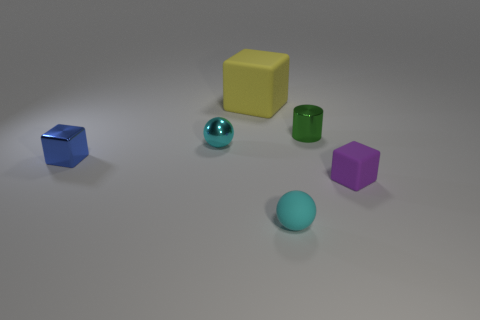Add 2 blue metal things. How many objects exist? 8 Subtract all cylinders. How many objects are left? 5 Subtract 0 yellow cylinders. How many objects are left? 6 Subtract all big yellow matte cubes. Subtract all small red metallic spheres. How many objects are left? 5 Add 1 metallic objects. How many metallic objects are left? 4 Add 6 tiny yellow cubes. How many tiny yellow cubes exist? 6 